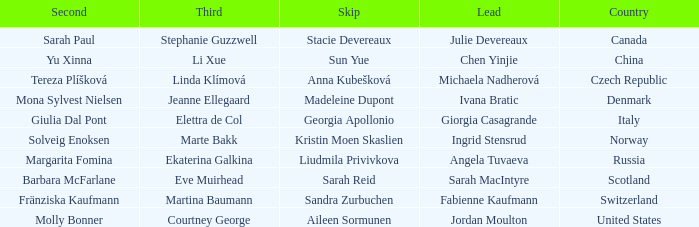What skip has switzerland as the country? Sandra Zurbuchen. 